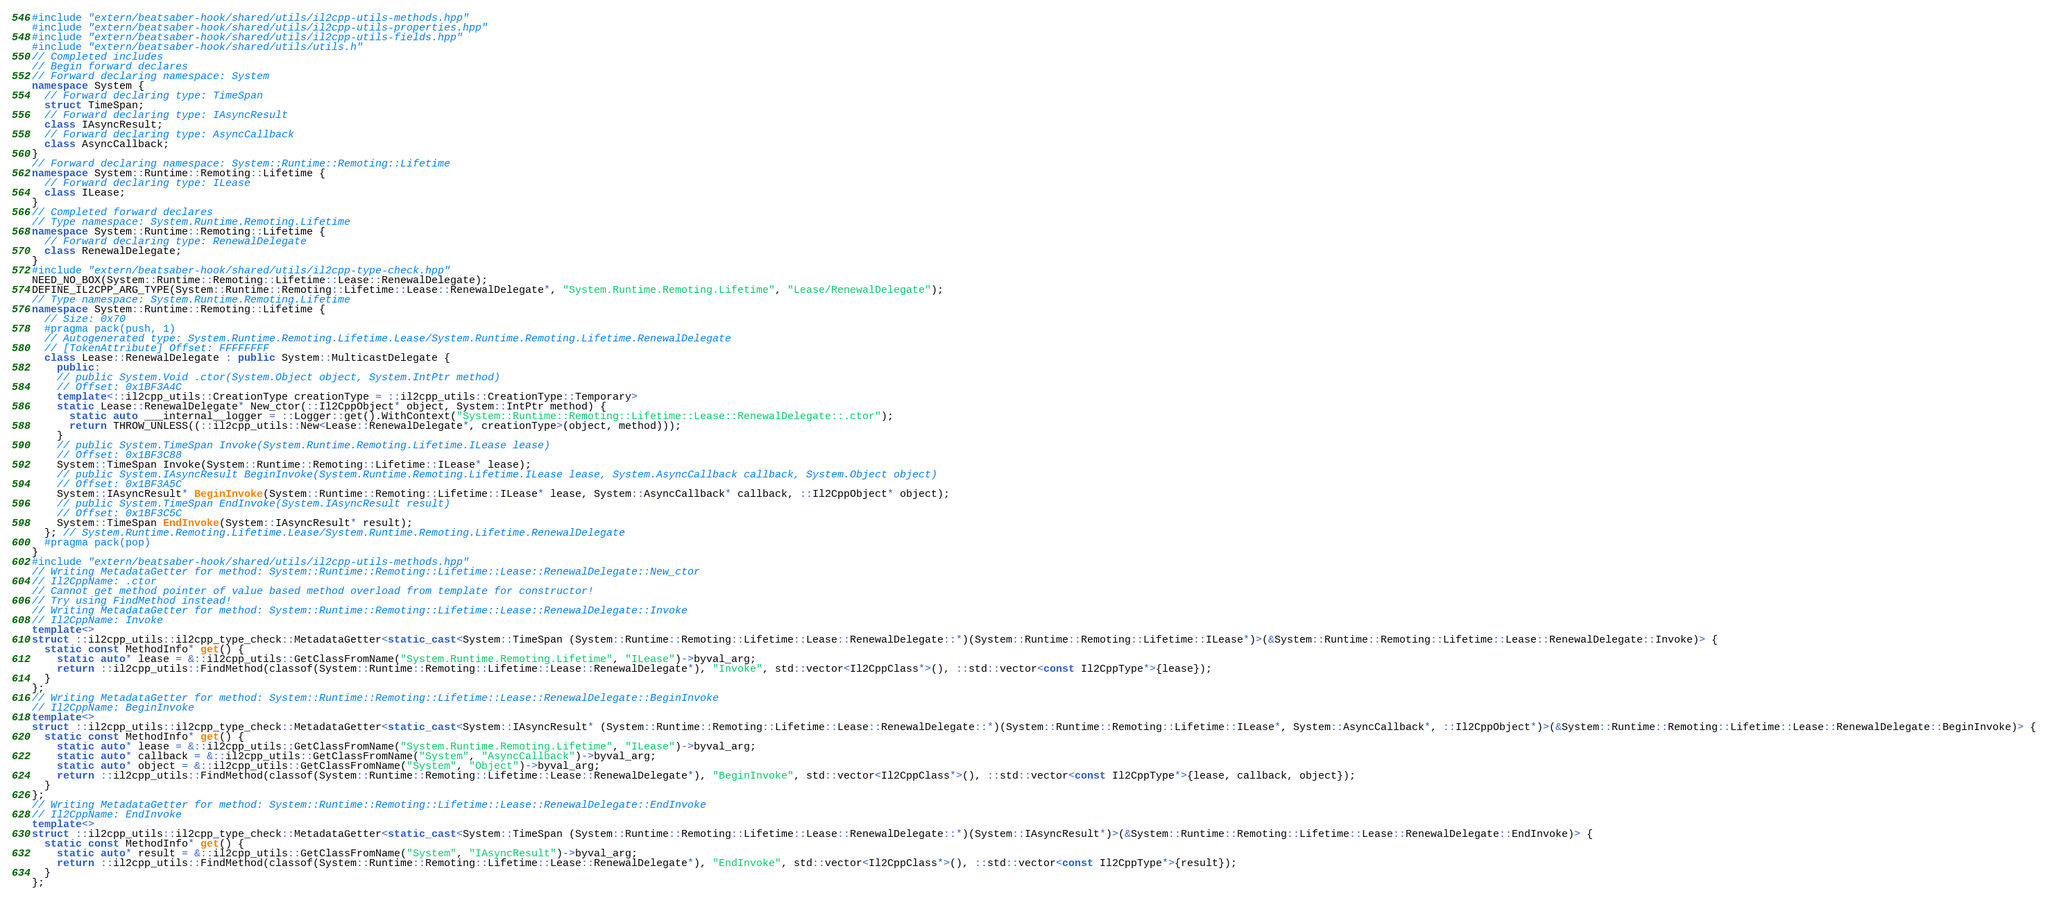<code> <loc_0><loc_0><loc_500><loc_500><_C++_>#include "extern/beatsaber-hook/shared/utils/il2cpp-utils-methods.hpp"
#include "extern/beatsaber-hook/shared/utils/il2cpp-utils-properties.hpp"
#include "extern/beatsaber-hook/shared/utils/il2cpp-utils-fields.hpp"
#include "extern/beatsaber-hook/shared/utils/utils.h"
// Completed includes
// Begin forward declares
// Forward declaring namespace: System
namespace System {
  // Forward declaring type: TimeSpan
  struct TimeSpan;
  // Forward declaring type: IAsyncResult
  class IAsyncResult;
  // Forward declaring type: AsyncCallback
  class AsyncCallback;
}
// Forward declaring namespace: System::Runtime::Remoting::Lifetime
namespace System::Runtime::Remoting::Lifetime {
  // Forward declaring type: ILease
  class ILease;
}
// Completed forward declares
// Type namespace: System.Runtime.Remoting.Lifetime
namespace System::Runtime::Remoting::Lifetime {
  // Forward declaring type: RenewalDelegate
  class RenewalDelegate;
}
#include "extern/beatsaber-hook/shared/utils/il2cpp-type-check.hpp"
NEED_NO_BOX(System::Runtime::Remoting::Lifetime::Lease::RenewalDelegate);
DEFINE_IL2CPP_ARG_TYPE(System::Runtime::Remoting::Lifetime::Lease::RenewalDelegate*, "System.Runtime.Remoting.Lifetime", "Lease/RenewalDelegate");
// Type namespace: System.Runtime.Remoting.Lifetime
namespace System::Runtime::Remoting::Lifetime {
  // Size: 0x70
  #pragma pack(push, 1)
  // Autogenerated type: System.Runtime.Remoting.Lifetime.Lease/System.Runtime.Remoting.Lifetime.RenewalDelegate
  // [TokenAttribute] Offset: FFFFFFFF
  class Lease::RenewalDelegate : public System::MulticastDelegate {
    public:
    // public System.Void .ctor(System.Object object, System.IntPtr method)
    // Offset: 0x1BF3A4C
    template<::il2cpp_utils::CreationType creationType = ::il2cpp_utils::CreationType::Temporary>
    static Lease::RenewalDelegate* New_ctor(::Il2CppObject* object, System::IntPtr method) {
      static auto ___internal__logger = ::Logger::get().WithContext("System::Runtime::Remoting::Lifetime::Lease::RenewalDelegate::.ctor");
      return THROW_UNLESS((::il2cpp_utils::New<Lease::RenewalDelegate*, creationType>(object, method)));
    }
    // public System.TimeSpan Invoke(System.Runtime.Remoting.Lifetime.ILease lease)
    // Offset: 0x1BF3C88
    System::TimeSpan Invoke(System::Runtime::Remoting::Lifetime::ILease* lease);
    // public System.IAsyncResult BeginInvoke(System.Runtime.Remoting.Lifetime.ILease lease, System.AsyncCallback callback, System.Object object)
    // Offset: 0x1BF3A5C
    System::IAsyncResult* BeginInvoke(System::Runtime::Remoting::Lifetime::ILease* lease, System::AsyncCallback* callback, ::Il2CppObject* object);
    // public System.TimeSpan EndInvoke(System.IAsyncResult result)
    // Offset: 0x1BF3C5C
    System::TimeSpan EndInvoke(System::IAsyncResult* result);
  }; // System.Runtime.Remoting.Lifetime.Lease/System.Runtime.Remoting.Lifetime.RenewalDelegate
  #pragma pack(pop)
}
#include "extern/beatsaber-hook/shared/utils/il2cpp-utils-methods.hpp"
// Writing MetadataGetter for method: System::Runtime::Remoting::Lifetime::Lease::RenewalDelegate::New_ctor
// Il2CppName: .ctor
// Cannot get method pointer of value based method overload from template for constructor!
// Try using FindMethod instead!
// Writing MetadataGetter for method: System::Runtime::Remoting::Lifetime::Lease::RenewalDelegate::Invoke
// Il2CppName: Invoke
template<>
struct ::il2cpp_utils::il2cpp_type_check::MetadataGetter<static_cast<System::TimeSpan (System::Runtime::Remoting::Lifetime::Lease::RenewalDelegate::*)(System::Runtime::Remoting::Lifetime::ILease*)>(&System::Runtime::Remoting::Lifetime::Lease::RenewalDelegate::Invoke)> {
  static const MethodInfo* get() {
    static auto* lease = &::il2cpp_utils::GetClassFromName("System.Runtime.Remoting.Lifetime", "ILease")->byval_arg;
    return ::il2cpp_utils::FindMethod(classof(System::Runtime::Remoting::Lifetime::Lease::RenewalDelegate*), "Invoke", std::vector<Il2CppClass*>(), ::std::vector<const Il2CppType*>{lease});
  }
};
// Writing MetadataGetter for method: System::Runtime::Remoting::Lifetime::Lease::RenewalDelegate::BeginInvoke
// Il2CppName: BeginInvoke
template<>
struct ::il2cpp_utils::il2cpp_type_check::MetadataGetter<static_cast<System::IAsyncResult* (System::Runtime::Remoting::Lifetime::Lease::RenewalDelegate::*)(System::Runtime::Remoting::Lifetime::ILease*, System::AsyncCallback*, ::Il2CppObject*)>(&System::Runtime::Remoting::Lifetime::Lease::RenewalDelegate::BeginInvoke)> {
  static const MethodInfo* get() {
    static auto* lease = &::il2cpp_utils::GetClassFromName("System.Runtime.Remoting.Lifetime", "ILease")->byval_arg;
    static auto* callback = &::il2cpp_utils::GetClassFromName("System", "AsyncCallback")->byval_arg;
    static auto* object = &::il2cpp_utils::GetClassFromName("System", "Object")->byval_arg;
    return ::il2cpp_utils::FindMethod(classof(System::Runtime::Remoting::Lifetime::Lease::RenewalDelegate*), "BeginInvoke", std::vector<Il2CppClass*>(), ::std::vector<const Il2CppType*>{lease, callback, object});
  }
};
// Writing MetadataGetter for method: System::Runtime::Remoting::Lifetime::Lease::RenewalDelegate::EndInvoke
// Il2CppName: EndInvoke
template<>
struct ::il2cpp_utils::il2cpp_type_check::MetadataGetter<static_cast<System::TimeSpan (System::Runtime::Remoting::Lifetime::Lease::RenewalDelegate::*)(System::IAsyncResult*)>(&System::Runtime::Remoting::Lifetime::Lease::RenewalDelegate::EndInvoke)> {
  static const MethodInfo* get() {
    static auto* result = &::il2cpp_utils::GetClassFromName("System", "IAsyncResult")->byval_arg;
    return ::il2cpp_utils::FindMethod(classof(System::Runtime::Remoting::Lifetime::Lease::RenewalDelegate*), "EndInvoke", std::vector<Il2CppClass*>(), ::std::vector<const Il2CppType*>{result});
  }
};
</code> 